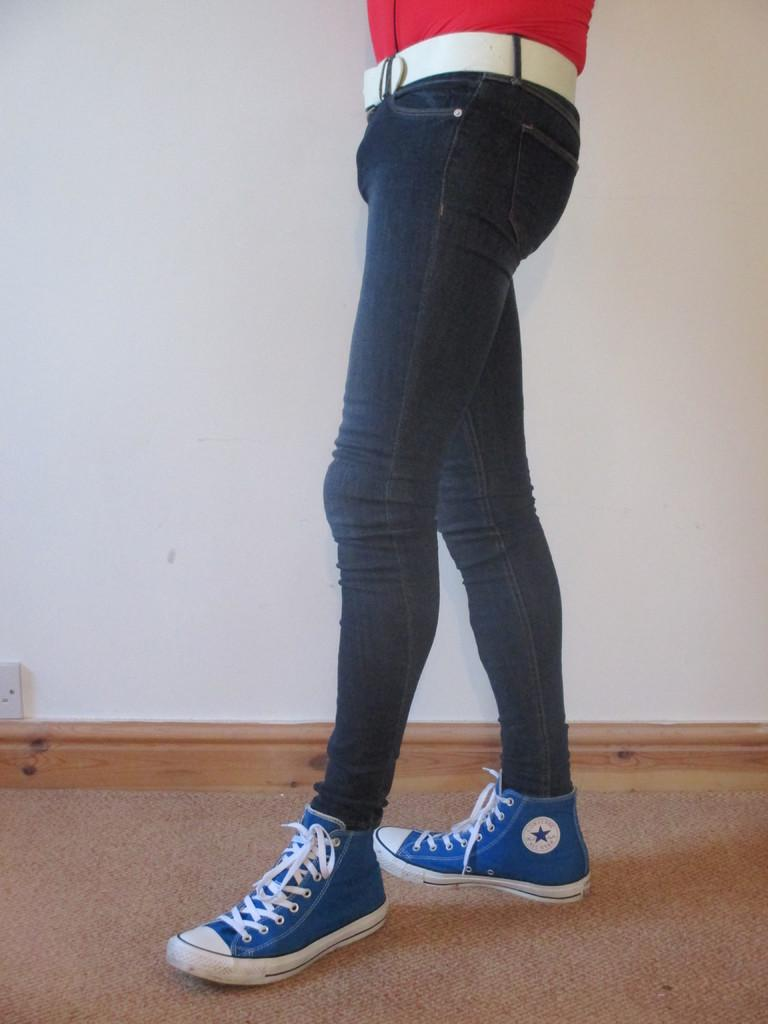What can be seen of the person in the image? Only half of a person is visible in the image. What type of clothing is the person wearing? The person is wearing jeans. What type of footwear is the person wearing? The person is wearing blue shoes. What is behind the person in the image? There is a wall behind the person in the image. What type of rod can be seen holding up the honey in the image? There is no rod or honey present in the image. How many clovers are visible in the image? There are no clovers visible in the image. 